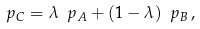Convert formula to latex. <formula><loc_0><loc_0><loc_500><loc_500>\ p _ { C } = \lambda \ p _ { A } + ( 1 - \lambda ) \ p _ { B } \, ,</formula> 